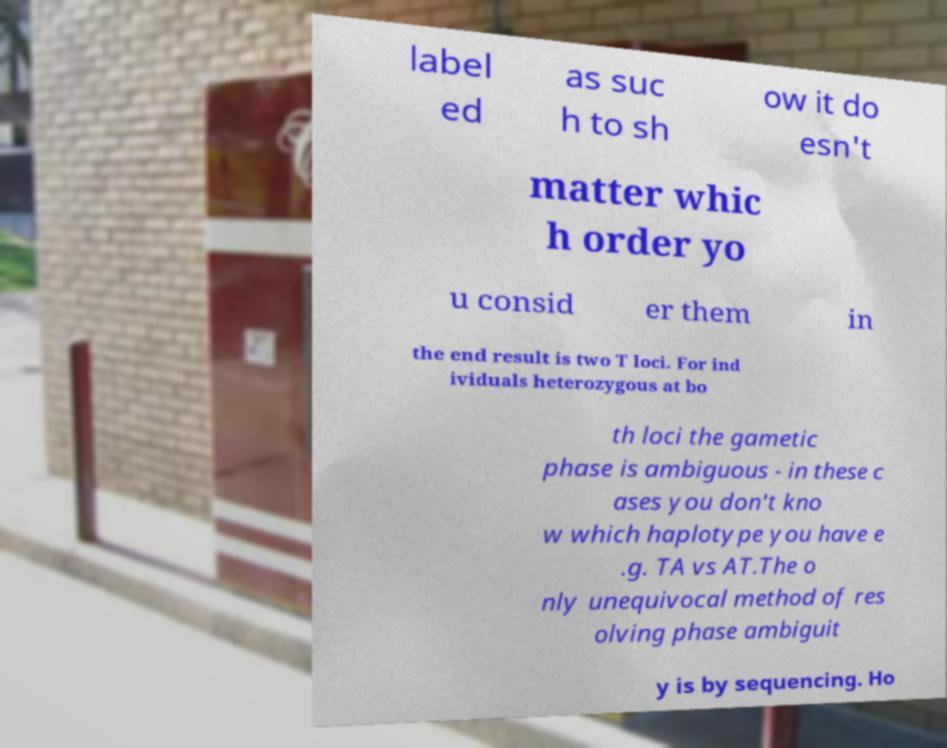I need the written content from this picture converted into text. Can you do that? label ed as suc h to sh ow it do esn't matter whic h order yo u consid er them in the end result is two T loci. For ind ividuals heterozygous at bo th loci the gametic phase is ambiguous - in these c ases you don't kno w which haplotype you have e .g. TA vs AT.The o nly unequivocal method of res olving phase ambiguit y is by sequencing. Ho 